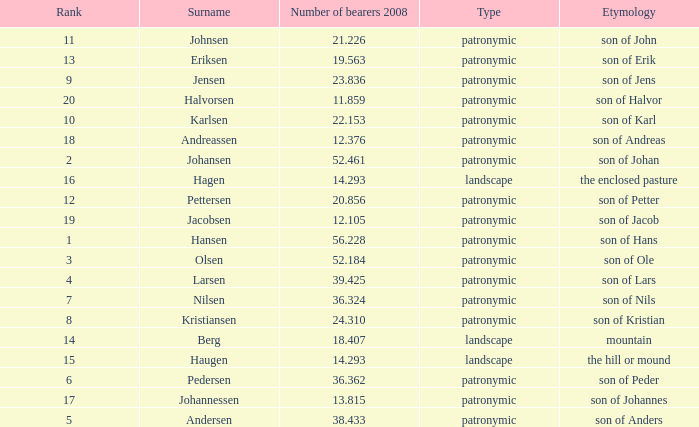What is Etymology, when Rank is 14? Mountain. 